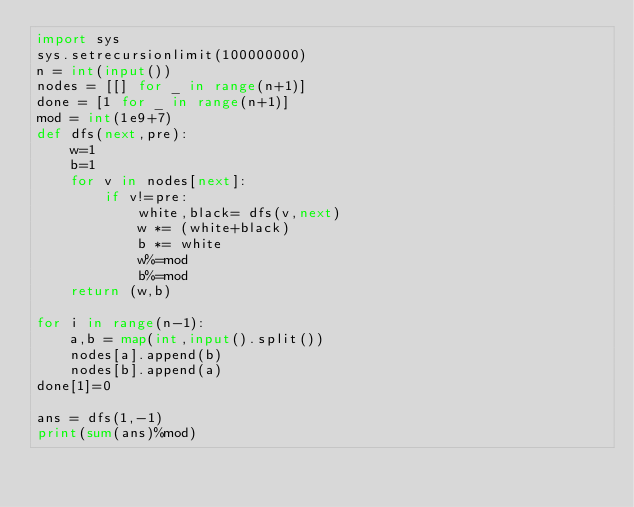<code> <loc_0><loc_0><loc_500><loc_500><_Python_>import sys
sys.setrecursionlimit(100000000)
n = int(input())
nodes = [[] for _ in range(n+1)]
done = [1 for _ in range(n+1)]
mod = int(1e9+7)
def dfs(next,pre):
    w=1
    b=1
    for v in nodes[next]:
        if v!=pre:
            white,black= dfs(v,next)
            w *= (white+black)
            b *= white
            w%=mod
            b%=mod
    return (w,b)

for i in range(n-1):
    a,b = map(int,input().split())
    nodes[a].append(b)
    nodes[b].append(a)
done[1]=0

ans = dfs(1,-1)
print(sum(ans)%mod)
</code> 